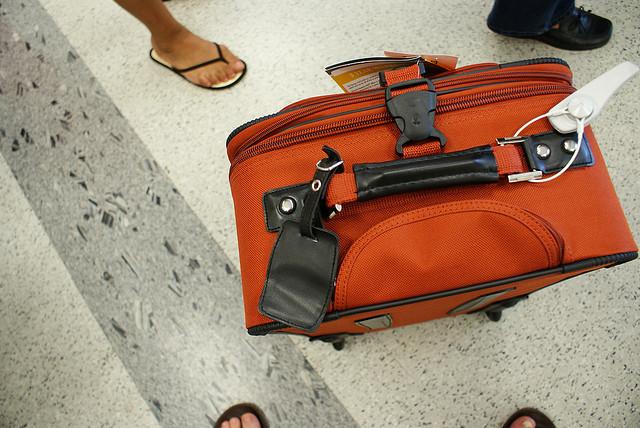Was this luggage taken from the luggage rack at an airport?
Answer briefly. Yes. How many big toes are visible?
Give a very brief answer. 3. Could someone come along and steal this bag?
Short answer required. Yes. 